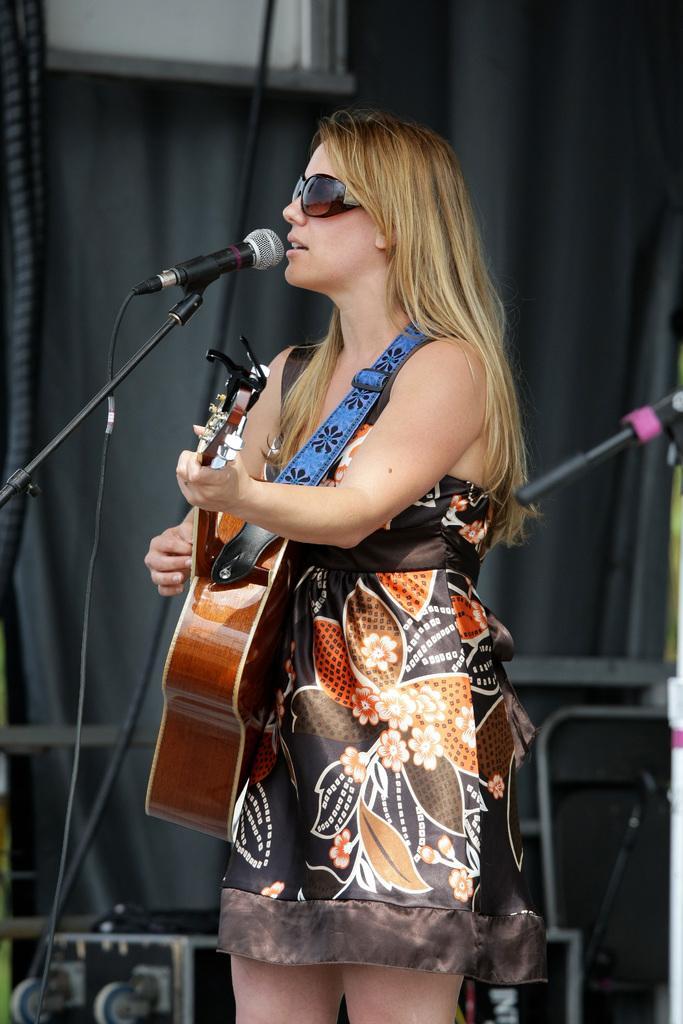Describe this image in one or two sentences. Here a woman is playing guitar and singing on mic. 